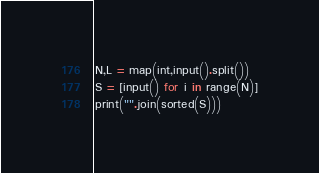Convert code to text. <code><loc_0><loc_0><loc_500><loc_500><_Python_>N,L = map(int,input().split())
S = [input() for i in range(N)]
print("".join(sorted(S)))</code> 